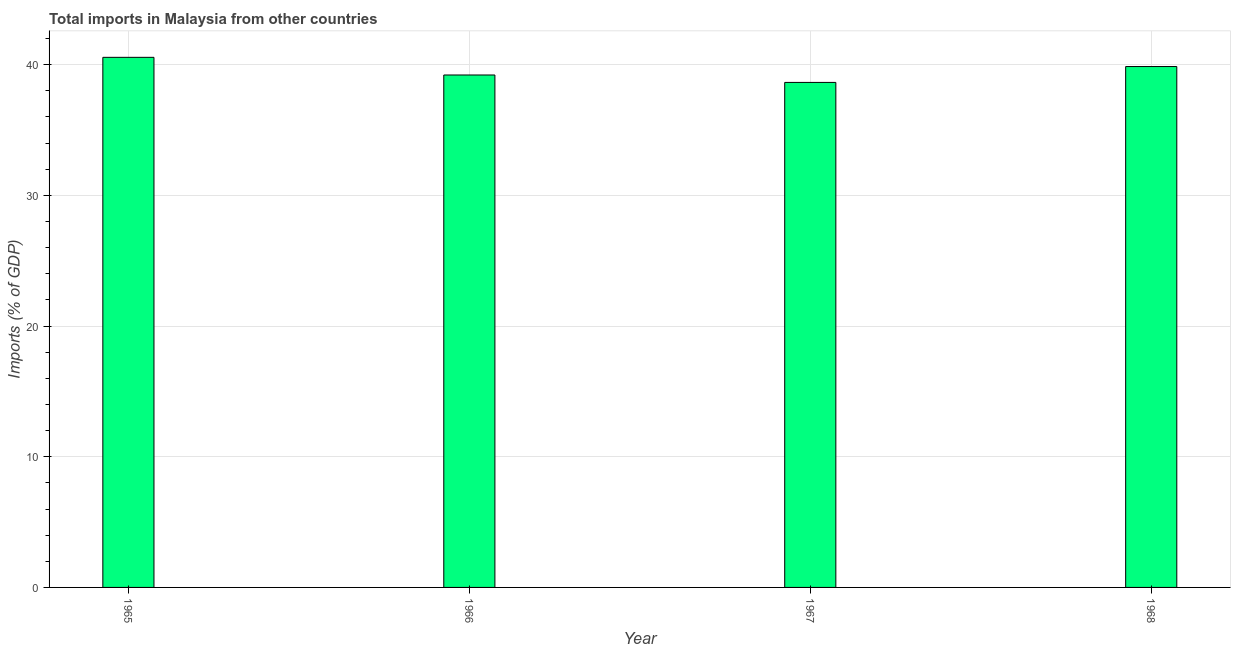Does the graph contain any zero values?
Offer a terse response. No. What is the title of the graph?
Ensure brevity in your answer.  Total imports in Malaysia from other countries. What is the label or title of the Y-axis?
Give a very brief answer. Imports (% of GDP). What is the total imports in 1966?
Make the answer very short. 39.21. Across all years, what is the maximum total imports?
Offer a very short reply. 40.56. Across all years, what is the minimum total imports?
Provide a succinct answer. 38.64. In which year was the total imports maximum?
Offer a terse response. 1965. In which year was the total imports minimum?
Your response must be concise. 1967. What is the sum of the total imports?
Keep it short and to the point. 158.27. What is the difference between the total imports in 1967 and 1968?
Your answer should be very brief. -1.22. What is the average total imports per year?
Your answer should be very brief. 39.57. What is the median total imports?
Provide a succinct answer. 39.53. In how many years, is the total imports greater than 6 %?
Your answer should be very brief. 4. What is the ratio of the total imports in 1966 to that in 1967?
Provide a short and direct response. 1.01. Is the difference between the total imports in 1965 and 1968 greater than the difference between any two years?
Make the answer very short. No. What is the difference between the highest and the second highest total imports?
Provide a succinct answer. 0.7. Is the sum of the total imports in 1965 and 1966 greater than the maximum total imports across all years?
Keep it short and to the point. Yes. What is the difference between the highest and the lowest total imports?
Provide a short and direct response. 1.92. What is the Imports (% of GDP) in 1965?
Keep it short and to the point. 40.56. What is the Imports (% of GDP) of 1966?
Offer a very short reply. 39.21. What is the Imports (% of GDP) of 1967?
Provide a succinct answer. 38.64. What is the Imports (% of GDP) of 1968?
Offer a very short reply. 39.86. What is the difference between the Imports (% of GDP) in 1965 and 1966?
Offer a very short reply. 1.35. What is the difference between the Imports (% of GDP) in 1965 and 1967?
Offer a very short reply. 1.92. What is the difference between the Imports (% of GDP) in 1965 and 1968?
Ensure brevity in your answer.  0.7. What is the difference between the Imports (% of GDP) in 1966 and 1967?
Offer a very short reply. 0.57. What is the difference between the Imports (% of GDP) in 1966 and 1968?
Your answer should be very brief. -0.65. What is the difference between the Imports (% of GDP) in 1967 and 1968?
Your response must be concise. -1.21. What is the ratio of the Imports (% of GDP) in 1965 to that in 1966?
Make the answer very short. 1.03. What is the ratio of the Imports (% of GDP) in 1966 to that in 1968?
Make the answer very short. 0.98. 